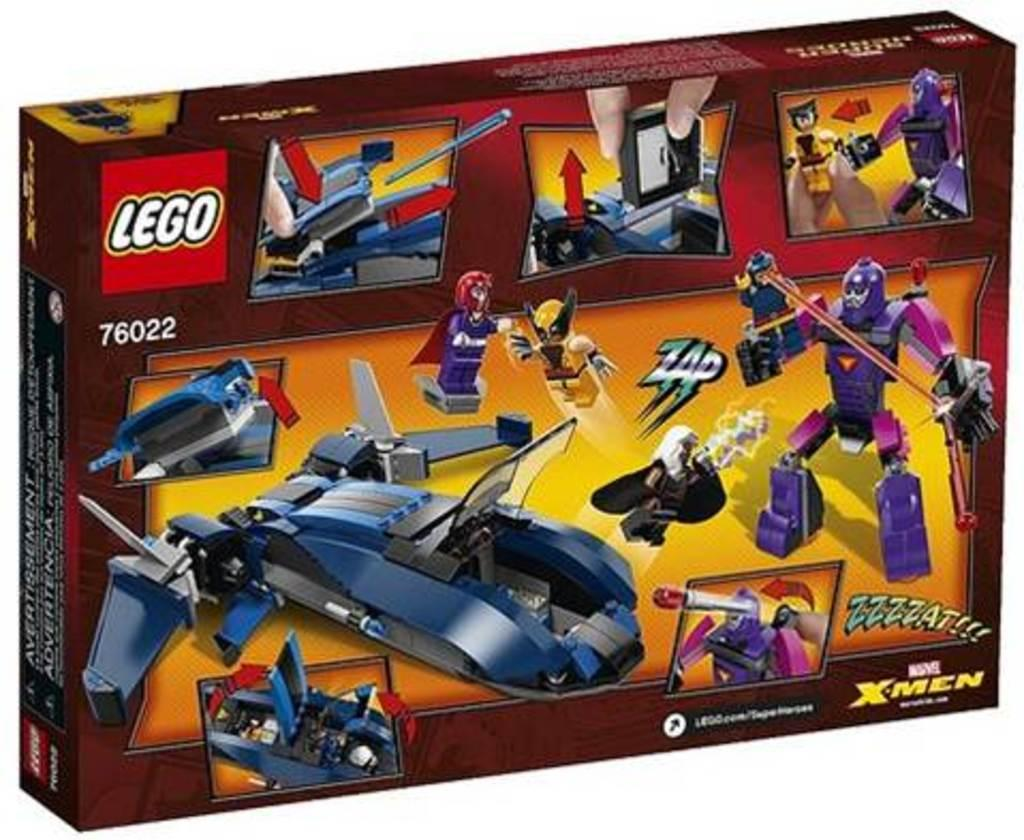What object is present in the image? There is a box in the image. What can be found on the surface of the box? There is writing on the box. What type of images are depicted on the box? There are images of robotic toys on the box. What type of powder can be seen on the moon in the image? There is no moon or powder present in the image; it only features a box with writing and images of robotic toys. 